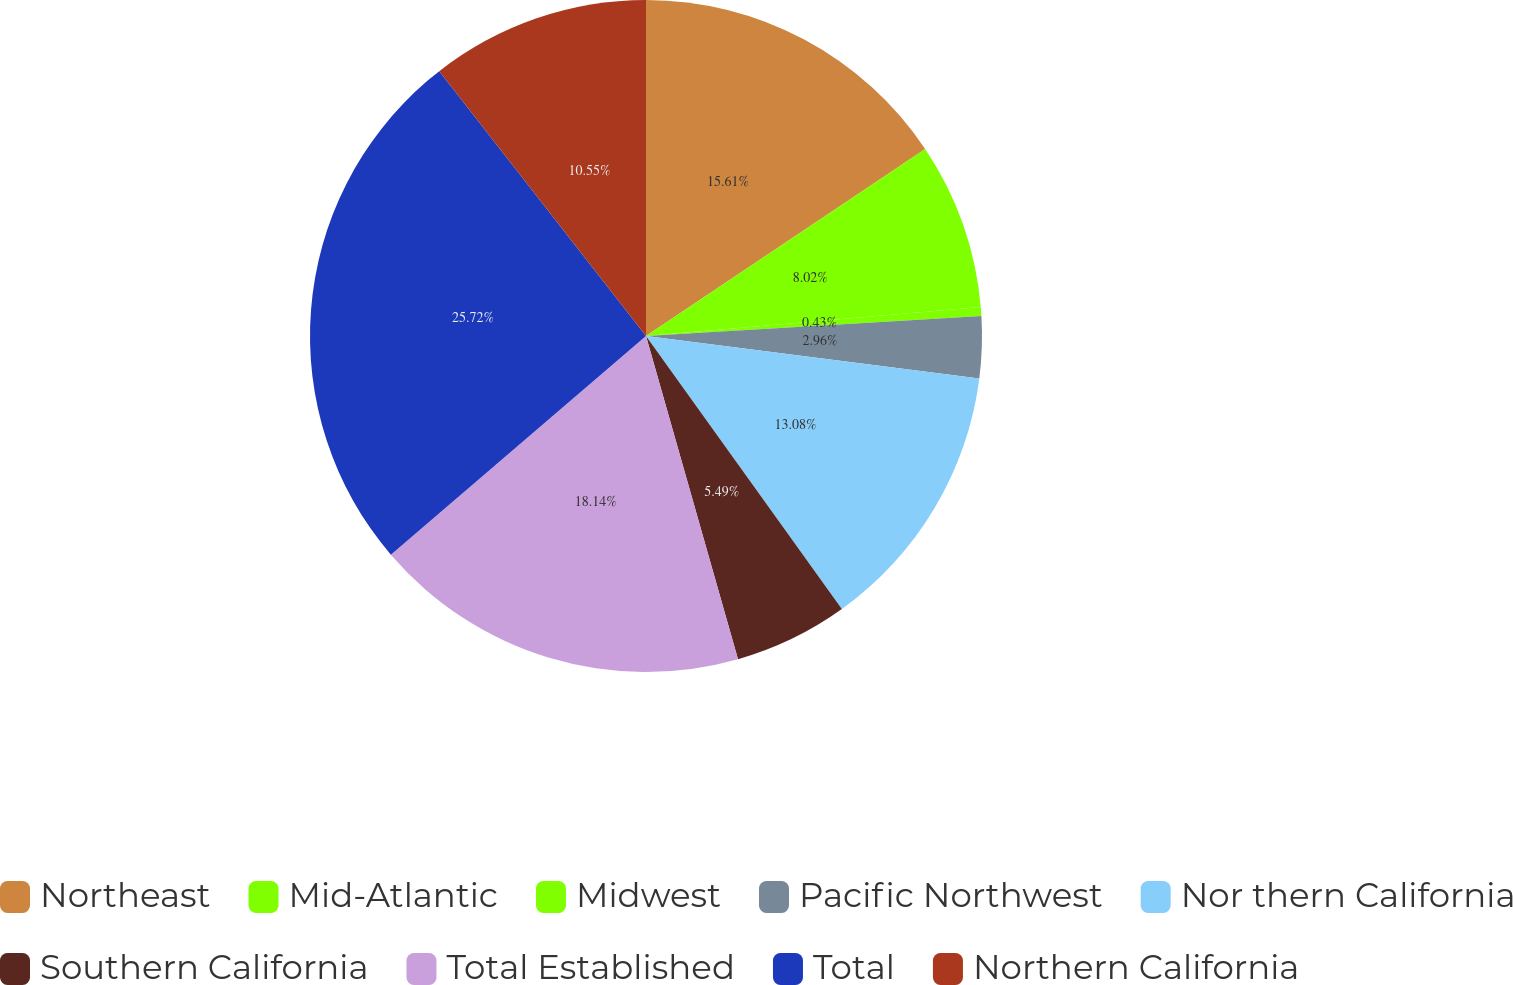<chart> <loc_0><loc_0><loc_500><loc_500><pie_chart><fcel>Northeast<fcel>Mid-Atlantic<fcel>Midwest<fcel>Pacific Northwest<fcel>Nor thern California<fcel>Southern California<fcel>Total Established<fcel>Total<fcel>Northern California<nl><fcel>15.61%<fcel>8.02%<fcel>0.43%<fcel>2.96%<fcel>13.08%<fcel>5.49%<fcel>18.14%<fcel>25.73%<fcel>10.55%<nl></chart> 